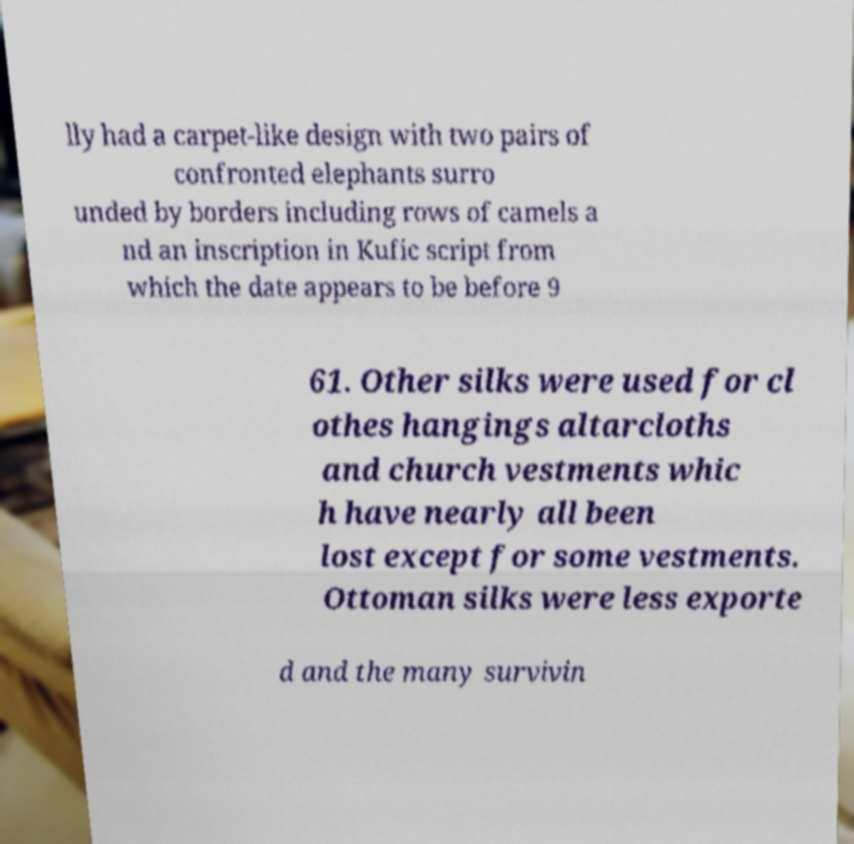For documentation purposes, I need the text within this image transcribed. Could you provide that? lly had a carpet-like design with two pairs of confronted elephants surro unded by borders including rows of camels a nd an inscription in Kufic script from which the date appears to be before 9 61. Other silks were used for cl othes hangings altarcloths and church vestments whic h have nearly all been lost except for some vestments. Ottoman silks were less exporte d and the many survivin 